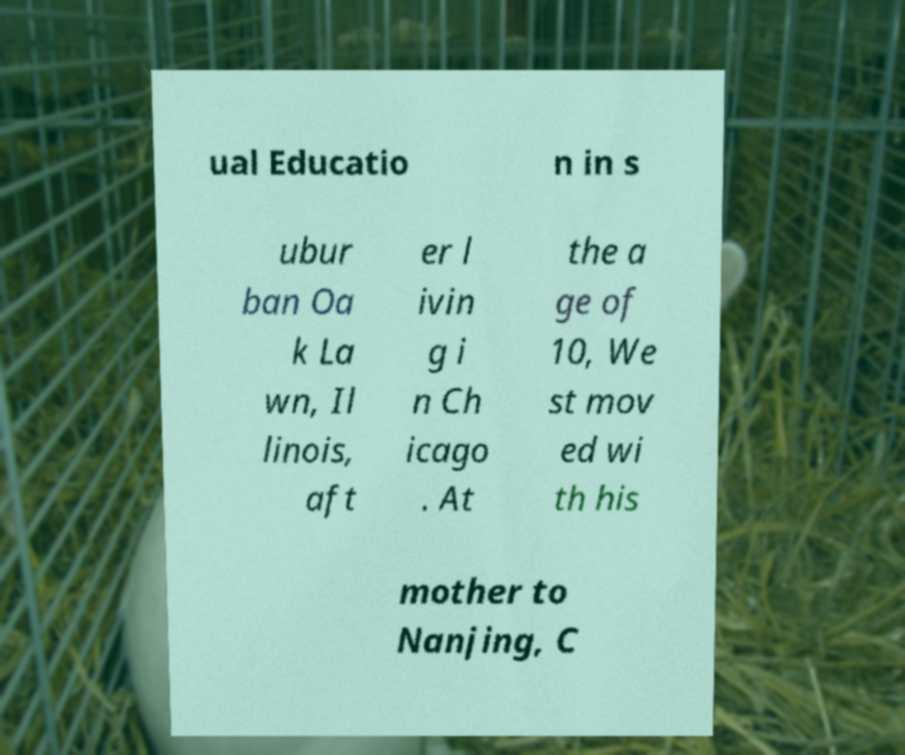Please identify and transcribe the text found in this image. ual Educatio n in s ubur ban Oa k La wn, Il linois, aft er l ivin g i n Ch icago . At the a ge of 10, We st mov ed wi th his mother to Nanjing, C 